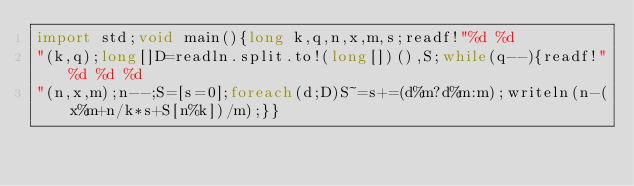Convert code to text. <code><loc_0><loc_0><loc_500><loc_500><_D_>import std;void main(){long k,q,n,x,m,s;readf!"%d %d
"(k,q);long[]D=readln.split.to!(long[])(),S;while(q--){readf!"%d %d %d
"(n,x,m);n--;S=[s=0];foreach(d;D)S~=s+=(d%m?d%m:m);writeln(n-(x%m+n/k*s+S[n%k])/m);}}</code> 